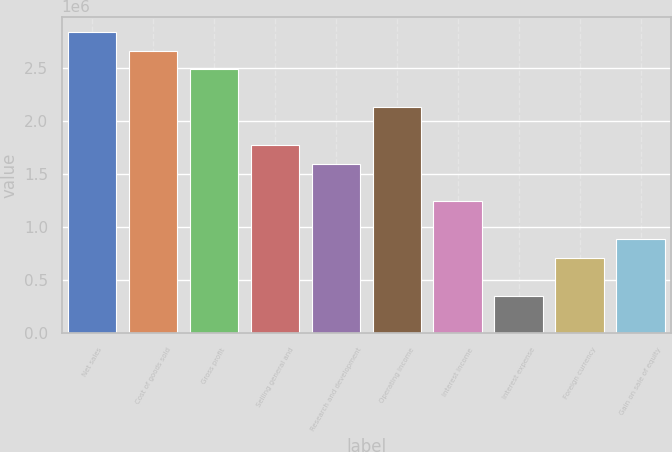Convert chart to OTSL. <chart><loc_0><loc_0><loc_500><loc_500><bar_chart><fcel>Net sales<fcel>Cost of goods sold<fcel>Gross profit<fcel>Selling general and<fcel>Research and development<fcel>Operating income<fcel>Interest income<fcel>Interest expense<fcel>Foreign currency<fcel>Gain on sale of equity<nl><fcel>2.8384e+06<fcel>2.661e+06<fcel>2.4836e+06<fcel>1.774e+06<fcel>1.5966e+06<fcel>2.1288e+06<fcel>1.2418e+06<fcel>354802<fcel>709601<fcel>887001<nl></chart> 